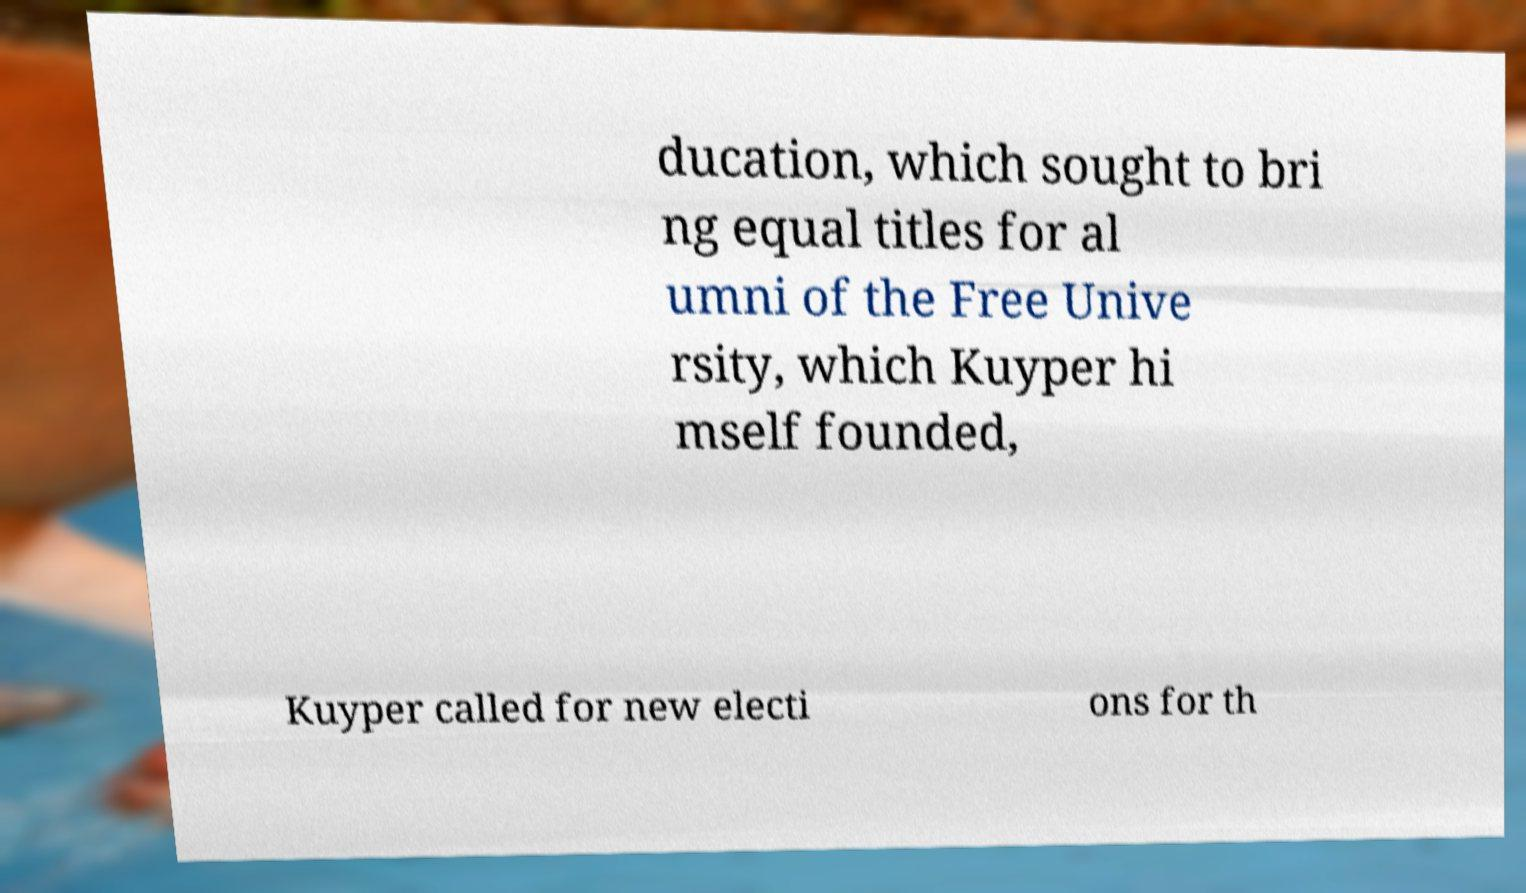There's text embedded in this image that I need extracted. Can you transcribe it verbatim? ducation, which sought to bri ng equal titles for al umni of the Free Unive rsity, which Kuyper hi mself founded, Kuyper called for new electi ons for th 